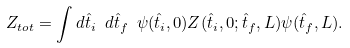Convert formula to latex. <formula><loc_0><loc_0><loc_500><loc_500>Z _ { t o t } = \int d { \hat { t } } _ { i } \ d { \hat { t } } _ { f } \ \psi ( { \hat { t } } _ { i } , 0 ) Z ( { \hat { t } } _ { i } , 0 ; { \hat { t } } _ { f } , L ) \psi ( { \hat { t } } _ { f } , L ) .</formula> 